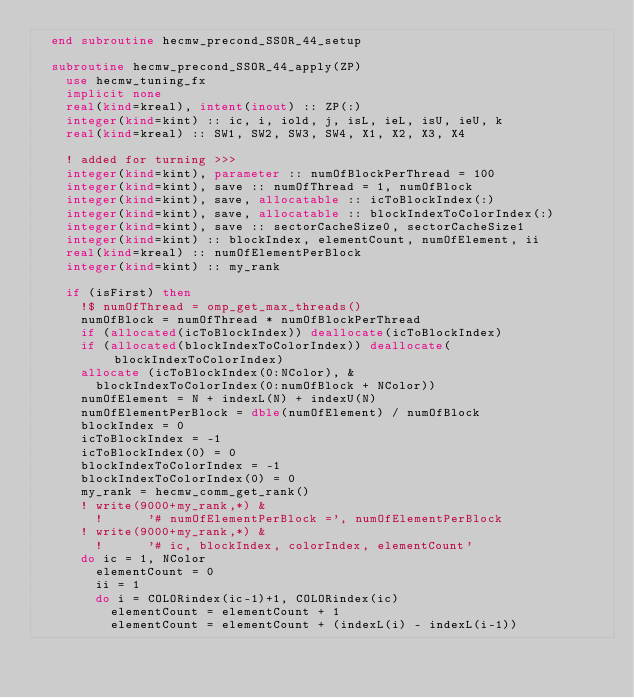Convert code to text. <code><loc_0><loc_0><loc_500><loc_500><_FORTRAN_>  end subroutine hecmw_precond_SSOR_44_setup

  subroutine hecmw_precond_SSOR_44_apply(ZP)
    use hecmw_tuning_fx
    implicit none
    real(kind=kreal), intent(inout) :: ZP(:)
    integer(kind=kint) :: ic, i, iold, j, isL, ieL, isU, ieU, k
    real(kind=kreal) :: SW1, SW2, SW3, SW4, X1, X2, X3, X4

    ! added for turning >>>
    integer(kind=kint), parameter :: numOfBlockPerThread = 100
    integer(kind=kint), save :: numOfThread = 1, numOfBlock
    integer(kind=kint), save, allocatable :: icToBlockIndex(:)
    integer(kind=kint), save, allocatable :: blockIndexToColorIndex(:)
    integer(kind=kint), save :: sectorCacheSize0, sectorCacheSize1
    integer(kind=kint) :: blockIndex, elementCount, numOfElement, ii
    real(kind=kreal) :: numOfElementPerBlock
    integer(kind=kint) :: my_rank

    if (isFirst) then
      !$ numOfThread = omp_get_max_threads()
      numOfBlock = numOfThread * numOfBlockPerThread
      if (allocated(icToBlockIndex)) deallocate(icToBlockIndex)
      if (allocated(blockIndexToColorIndex)) deallocate(blockIndexToColorIndex)
      allocate (icToBlockIndex(0:NColor), &
        blockIndexToColorIndex(0:numOfBlock + NColor))
      numOfElement = N + indexL(N) + indexU(N)
      numOfElementPerBlock = dble(numOfElement) / numOfBlock
      blockIndex = 0
      icToBlockIndex = -1
      icToBlockIndex(0) = 0
      blockIndexToColorIndex = -1
      blockIndexToColorIndex(0) = 0
      my_rank = hecmw_comm_get_rank()
      ! write(9000+my_rank,*) &
        !      '# numOfElementPerBlock =', numOfElementPerBlock
      ! write(9000+my_rank,*) &
        !      '# ic, blockIndex, colorIndex, elementCount'
      do ic = 1, NColor
        elementCount = 0
        ii = 1
        do i = COLORindex(ic-1)+1, COLORindex(ic)
          elementCount = elementCount + 1
          elementCount = elementCount + (indexL(i) - indexL(i-1))</code> 